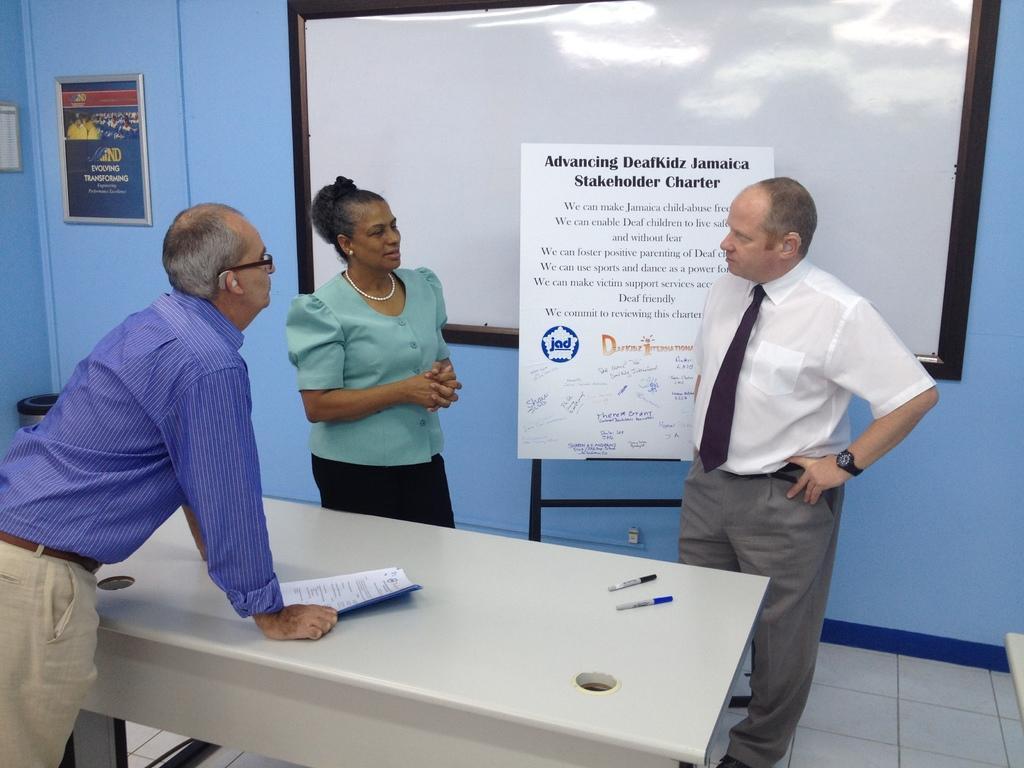Can you describe this image briefly? In the image we can see there are people who are standing and on table there are papers and markers. Behind the person there is a banner board on which it's written in a black paint. On the wall there is a photo frame. 